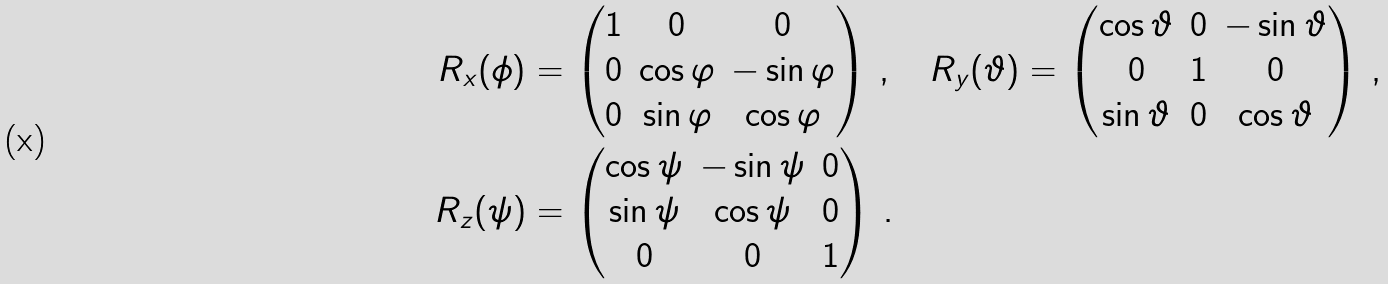Convert formula to latex. <formula><loc_0><loc_0><loc_500><loc_500>R _ { x } ( \phi ) & = \begin{pmatrix} 1 & 0 & 0 \\ 0 & \cos \varphi & - \sin \varphi \\ 0 & \sin \varphi & \cos \varphi \end{pmatrix} \, , \quad R _ { y } ( \vartheta ) = \begin{pmatrix} \cos \vartheta & 0 & - \sin \vartheta \\ 0 & 1 & 0 \\ \sin \vartheta & 0 & \cos \vartheta \end{pmatrix} \, , \\ R _ { z } ( \psi ) & = \begin{pmatrix} \cos \psi & - \sin \psi & 0 \\ \sin \psi & \cos \psi & 0 \\ 0 & 0 & 1 \end{pmatrix} \, .</formula> 